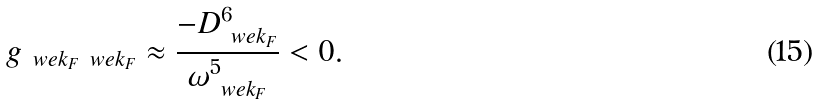Convert formula to latex. <formula><loc_0><loc_0><loc_500><loc_500>g _ { \ w e { k } _ { F } \ w e { k } _ { F } } \approx \frac { - D _ { \ w e { k } _ { F } } ^ { 6 } } { \omega _ { \ w e { k } _ { F } } ^ { 5 } } < 0 .</formula> 